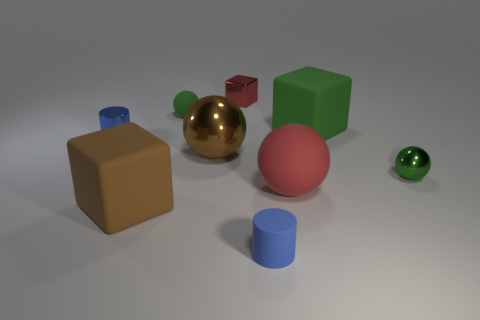There is a big ball that is behind the red thing that is to the right of the tiny cylinder in front of the small blue shiny cylinder; what is it made of?
Keep it short and to the point. Metal. What is the material of the small cube?
Provide a short and direct response. Metal. What is the size of the brown thing that is the same shape as the tiny red object?
Keep it short and to the point. Large. Is the color of the metal cube the same as the large matte ball?
Your response must be concise. Yes. What number of other objects are the same material as the large green object?
Provide a short and direct response. 4. Are there the same number of brown balls right of the large red thing and green shiny spheres?
Provide a succinct answer. No. There is a brown object behind the brown matte cube; does it have the same size as the large red object?
Your answer should be compact. Yes. There is a tiny red shiny object; what number of blocks are left of it?
Ensure brevity in your answer.  1. There is a cube that is both left of the rubber cylinder and in front of the tiny red metal block; what material is it?
Make the answer very short. Rubber. What number of small things are blue matte cylinders or red things?
Provide a succinct answer. 2. 